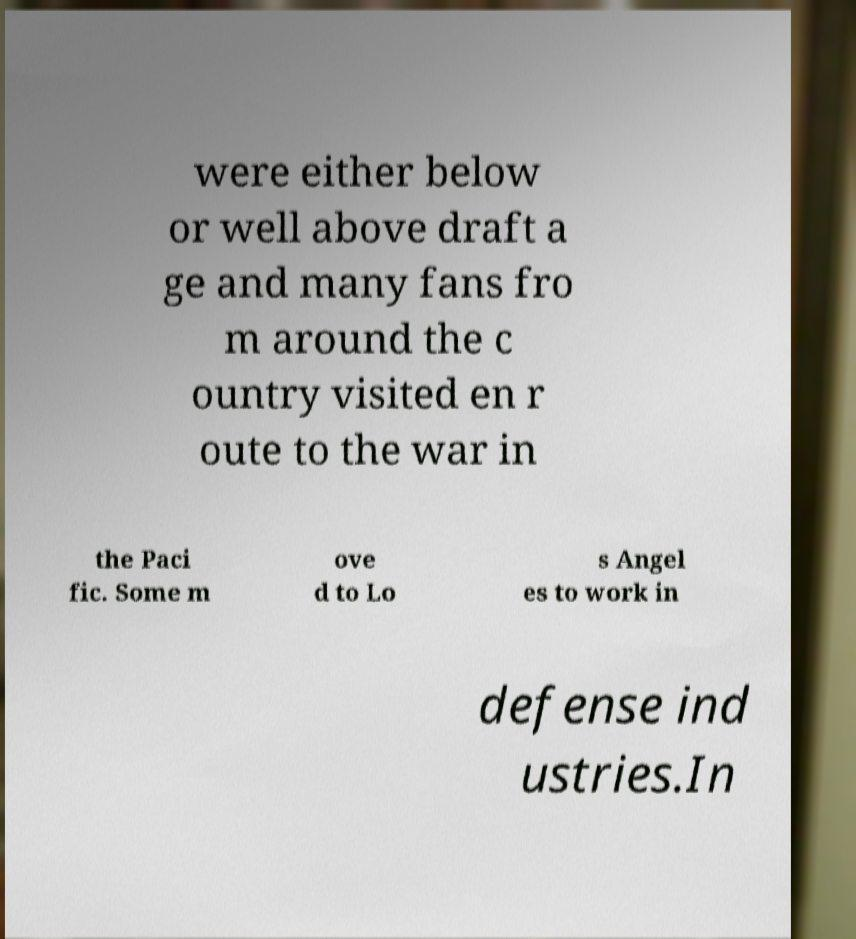Can you accurately transcribe the text from the provided image for me? were either below or well above draft a ge and many fans fro m around the c ountry visited en r oute to the war in the Paci fic. Some m ove d to Lo s Angel es to work in defense ind ustries.In 